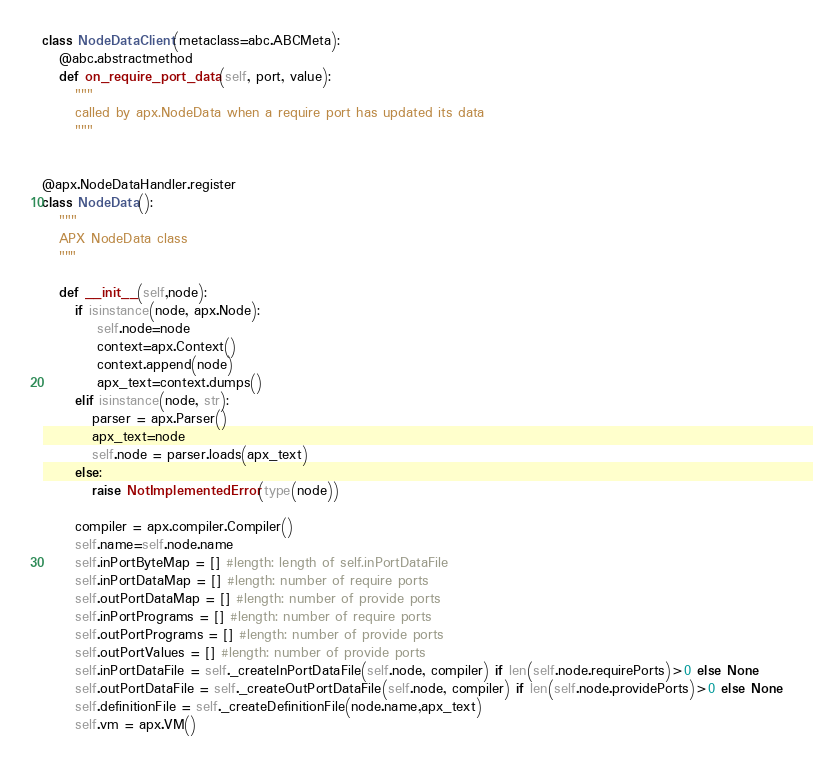Convert code to text. <code><loc_0><loc_0><loc_500><loc_500><_Python_>class NodeDataClient(metaclass=abc.ABCMeta):
   @abc.abstractmethod
   def on_require_port_data(self, port, value):
      """
      called by apx.NodeData when a require port has updated its data
      """


@apx.NodeDataHandler.register
class NodeData():
   """
   APX NodeData class
   """

   def __init__(self,node):
      if isinstance(node, apx.Node):
          self.node=node
          context=apx.Context()
          context.append(node)
          apx_text=context.dumps()
      elif isinstance(node, str):
         parser = apx.Parser()
         apx_text=node
         self.node = parser.loads(apx_text)
      else:
         raise NotImplementedError(type(node))

      compiler = apx.compiler.Compiler()
      self.name=self.node.name
      self.inPortByteMap = [] #length: length of self.inPortDataFile
      self.inPortDataMap = [] #length: number of require ports
      self.outPortDataMap = [] #length: number of provide ports
      self.inPortPrograms = [] #length: number of require ports
      self.outPortPrograms = [] #length: number of provide ports
      self.outPortValues = [] #length: number of provide ports
      self.inPortDataFile = self._createInPortDataFile(self.node, compiler) if len(self.node.requirePorts)>0 else None
      self.outPortDataFile = self._createOutPortDataFile(self.node, compiler) if len(self.node.providePorts)>0 else None
      self.definitionFile = self._createDefinitionFile(node.name,apx_text)
      self.vm = apx.VM()</code> 